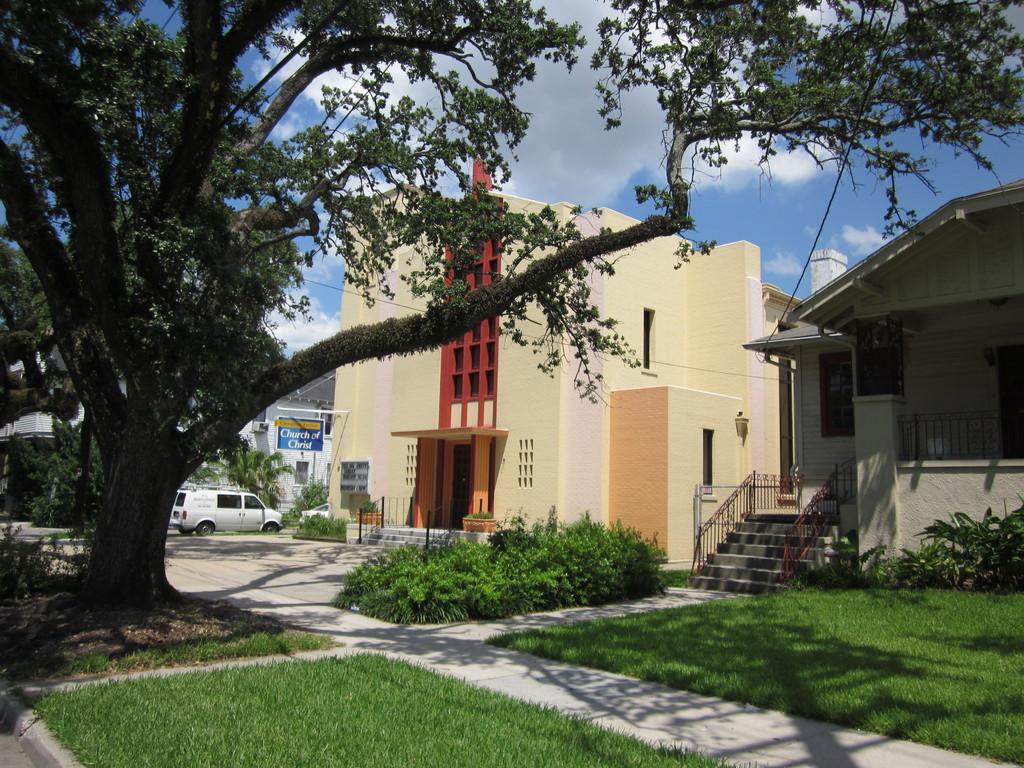Please provide a concise description of this image. This picture shows few buildings and a car parked on the side and we see trees and few plants and grass on the ground and we see a blue cloudy sky. 